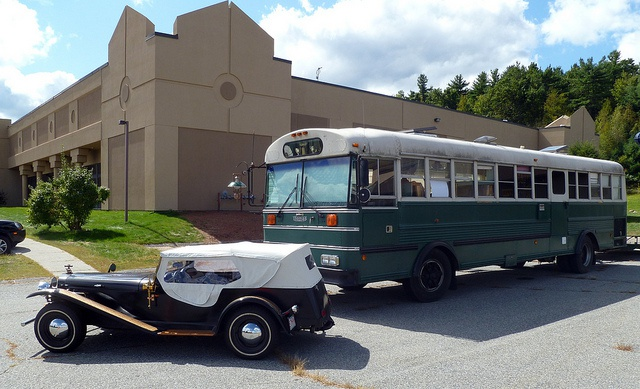Describe the objects in this image and their specific colors. I can see bus in white, black, gray, and darkgray tones, car in white, black, darkgray, and gray tones, and car in white, black, gray, olive, and darkgray tones in this image. 